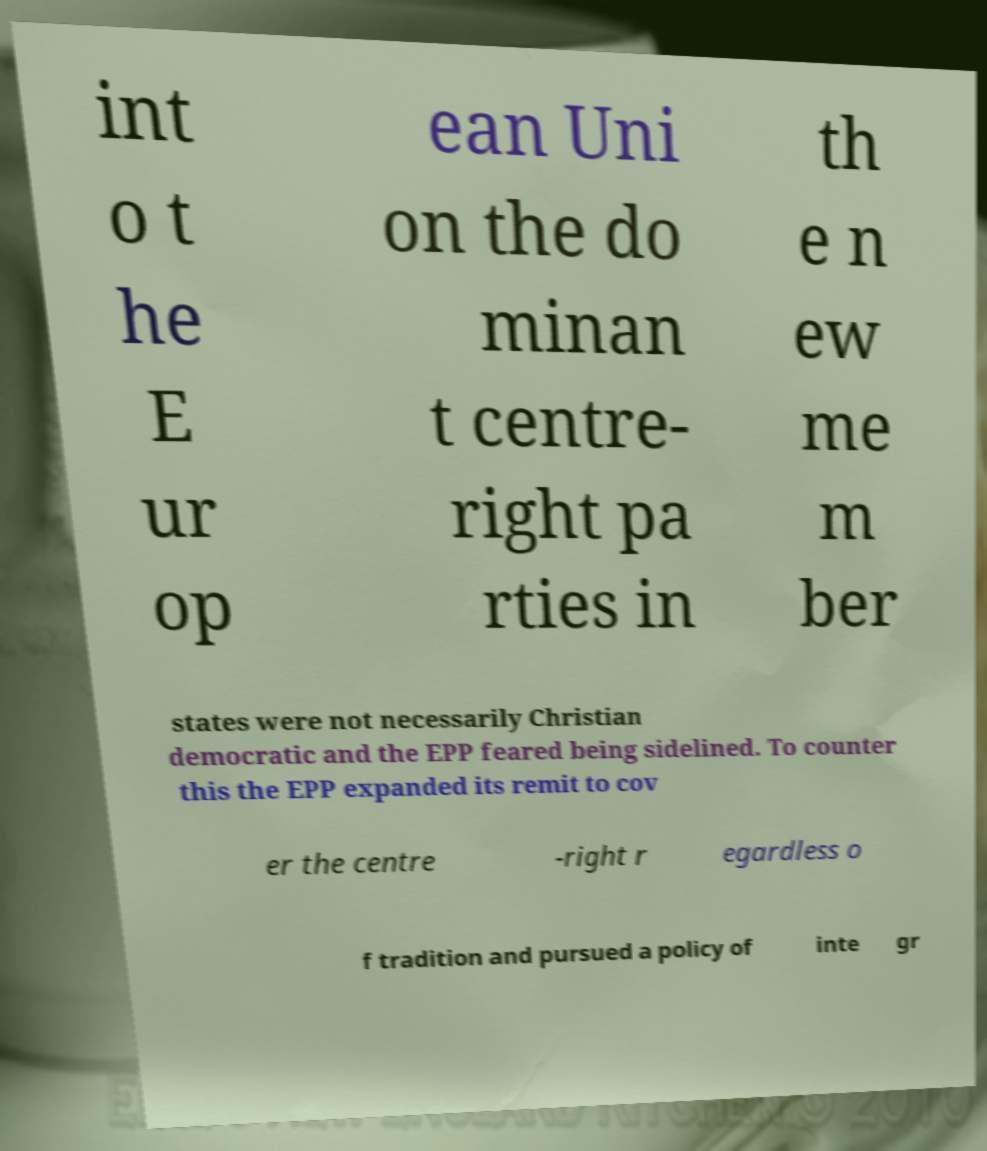Could you extract and type out the text from this image? int o t he E ur op ean Uni on the do minan t centre- right pa rties in th e n ew me m ber states were not necessarily Christian democratic and the EPP feared being sidelined. To counter this the EPP expanded its remit to cov er the centre -right r egardless o f tradition and pursued a policy of inte gr 